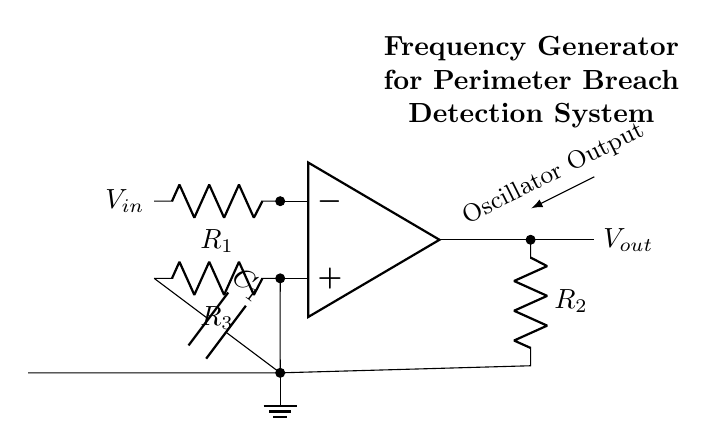What is the type of this circuit? The circuit is an oscillator, which generates a periodic output signal. This is indicated by the presence of an op-amp and capacitive elements configured for feedback, typical in oscillators.
Answer: oscillator What is the purpose of the capacitor in this circuit? The capacitor is used to store and release charge, which helps determine the frequency of oscillation. In this circuit, it is crucial for setting the time constant along with the resistor to create the desired output frequency.
Answer: frequency control What does Vout represent? Vout represents the output voltage of the oscillator circuit, which is the signal generated by the op-amp and is available at the output terminal.
Answer: output voltage How many resistors are present in the circuit? There are three resistors indicated in the circuit diagram. They are labeled R1, R2, and R3, each serving a specific role in regulating voltage and controlling oscillation parameters.
Answer: three What is the role of R3 in the circuit? R3 is connected to the non-inverting terminal of the op-amp and serves to set the gain of the op-amp in conjunction with R1, affecting the stability and frequency of the output signal.
Answer: gain setting What output characteristic does this frequency generator provide? The frequency generator provides an output signal that oscillates, indicating a repeatable and periodic waveform that is essential for perimeter breach detection.
Answer: periodic waveform How does changing R2 affect the oscillator's performance? Changing R2 will alter the voltage drop across it, influencing the feedback into the op-amp. This can affect the amplitude and stability of the oscillations, thereby altering how effectively the system detects perimeter breaches.
Answer: alters amplitude 